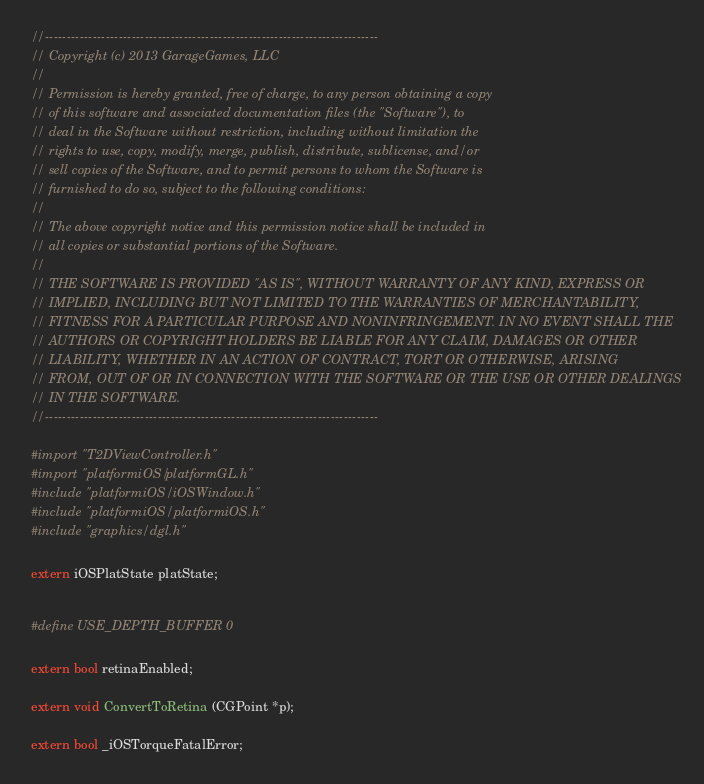Convert code to text. <code><loc_0><loc_0><loc_500><loc_500><_ObjectiveC_>//-----------------------------------------------------------------------------
// Copyright (c) 2013 GarageGames, LLC
//
// Permission is hereby granted, free of charge, to any person obtaining a copy
// of this software and associated documentation files (the "Software"), to
// deal in the Software without restriction, including without limitation the
// rights to use, copy, modify, merge, publish, distribute, sublicense, and/or
// sell copies of the Software, and to permit persons to whom the Software is
// furnished to do so, subject to the following conditions:
//
// The above copyright notice and this permission notice shall be included in
// all copies or substantial portions of the Software.
//
// THE SOFTWARE IS PROVIDED "AS IS", WITHOUT WARRANTY OF ANY KIND, EXPRESS OR
// IMPLIED, INCLUDING BUT NOT LIMITED TO THE WARRANTIES OF MERCHANTABILITY,
// FITNESS FOR A PARTICULAR PURPOSE AND NONINFRINGEMENT. IN NO EVENT SHALL THE
// AUTHORS OR COPYRIGHT HOLDERS BE LIABLE FOR ANY CLAIM, DAMAGES OR OTHER
// LIABILITY, WHETHER IN AN ACTION OF CONTRACT, TORT OR OTHERWISE, ARISING
// FROM, OUT OF OR IN CONNECTION WITH THE SOFTWARE OR THE USE OR OTHER DEALINGS
// IN THE SOFTWARE.
//-----------------------------------------------------------------------------

#import "T2DViewController.h"
#import "platformiOS/platformGL.h"
#include "platformiOS/iOSWindow.h"
#include "platformiOS/platformiOS.h"
#include "graphics/dgl.h"

extern iOSPlatState platState;


#define USE_DEPTH_BUFFER 0

extern bool retinaEnabled;

extern void ConvertToRetina (CGPoint *p);

extern bool _iOSTorqueFatalError;</code> 